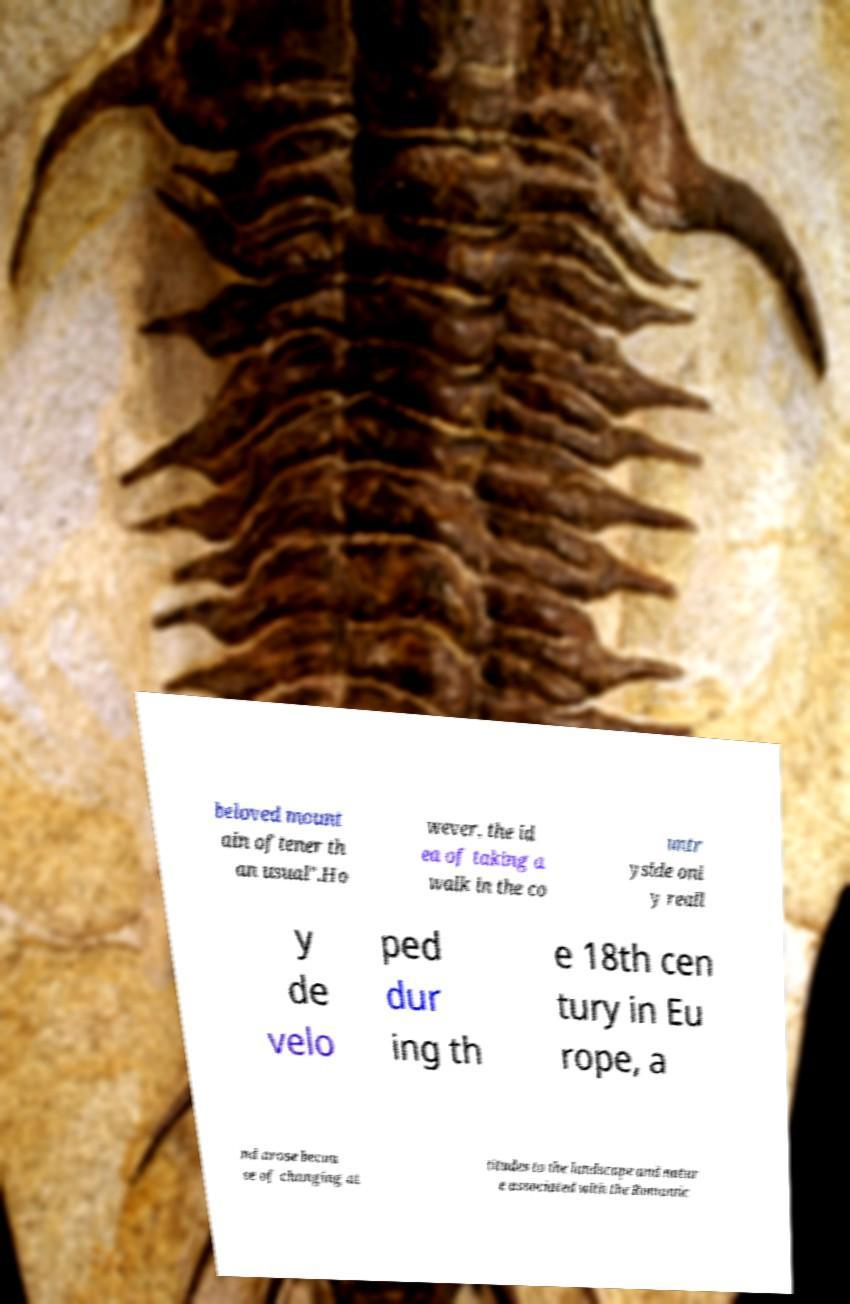I need the written content from this picture converted into text. Can you do that? beloved mount ain oftener th an usual".Ho wever, the id ea of taking a walk in the co untr yside onl y reall y de velo ped dur ing th e 18th cen tury in Eu rope, a nd arose becau se of changing at titudes to the landscape and natur e associated with the Romantic 